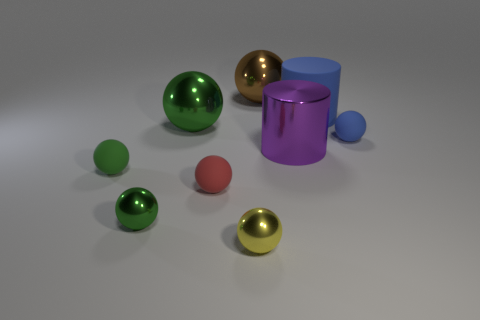What shape is the tiny rubber thing that is the same color as the big rubber cylinder?
Offer a terse response. Sphere. There is a tiny object to the right of the metallic thing that is behind the large blue rubber cylinder; what is it made of?
Give a very brief answer. Rubber. Are there more large brown objects behind the brown object than red rubber objects?
Ensure brevity in your answer.  No. Is there a small blue object that has the same material as the brown thing?
Offer a terse response. No. Is the shape of the green metallic object behind the red ball the same as  the small yellow object?
Ensure brevity in your answer.  Yes. How many tiny things are behind the large object in front of the matte ball that is behind the green matte thing?
Make the answer very short. 1. Is the number of rubber balls that are right of the big green thing less than the number of shiny objects that are in front of the large matte object?
Keep it short and to the point. Yes. What color is the other small metal object that is the same shape as the yellow object?
Provide a short and direct response. Green. How big is the brown shiny ball?
Your answer should be compact. Large. How many red matte balls are the same size as the purple shiny thing?
Make the answer very short. 0. 